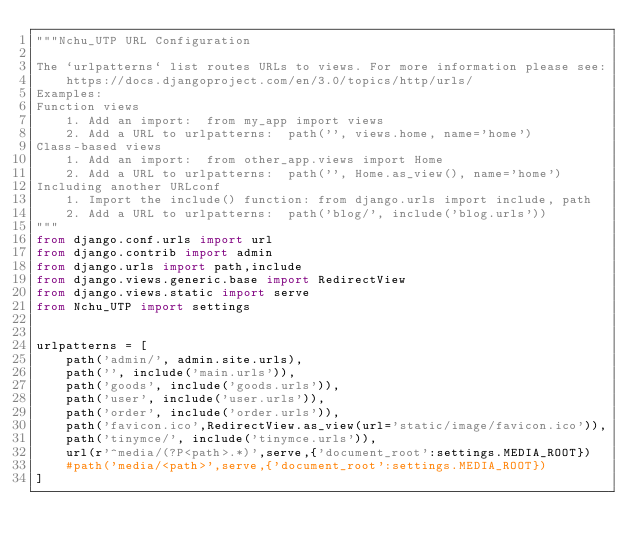Convert code to text. <code><loc_0><loc_0><loc_500><loc_500><_Python_>"""Nchu_UTP URL Configuration

The `urlpatterns` list routes URLs to views. For more information please see:
    https://docs.djangoproject.com/en/3.0/topics/http/urls/
Examples:
Function views
    1. Add an import:  from my_app import views
    2. Add a URL to urlpatterns:  path('', views.home, name='home')
Class-based views
    1. Add an import:  from other_app.views import Home
    2. Add a URL to urlpatterns:  path('', Home.as_view(), name='home')
Including another URLconf
    1. Import the include() function: from django.urls import include, path
    2. Add a URL to urlpatterns:  path('blog/', include('blog.urls'))
"""
from django.conf.urls import url
from django.contrib import admin
from django.urls import path,include
from django.views.generic.base import RedirectView
from django.views.static import serve
from Nchu_UTP import settings


urlpatterns = [
    path('admin/', admin.site.urls),
    path('', include('main.urls')),
    path('goods', include('goods.urls')),
    path('user', include('user.urls')),
    path('order', include('order.urls')),
    path('favicon.ico',RedirectView.as_view(url='static/image/favicon.ico')),
    path('tinymce/', include('tinymce.urls')),
    url(r'^media/(?P<path>.*)',serve,{'document_root':settings.MEDIA_ROOT})
    #path('media/<path>',serve,{'document_root':settings.MEDIA_ROOT})
]
</code> 